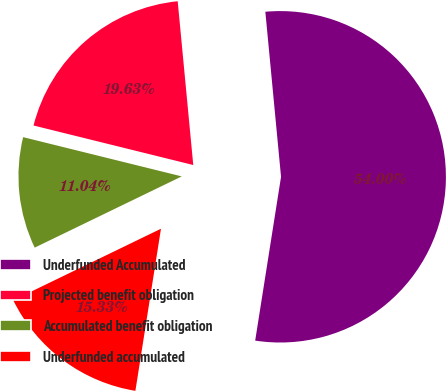<chart> <loc_0><loc_0><loc_500><loc_500><pie_chart><fcel>Underfunded Accumulated<fcel>Projected benefit obligation<fcel>Accumulated benefit obligation<fcel>Underfunded accumulated<nl><fcel>54.0%<fcel>19.63%<fcel>11.04%<fcel>15.33%<nl></chart> 